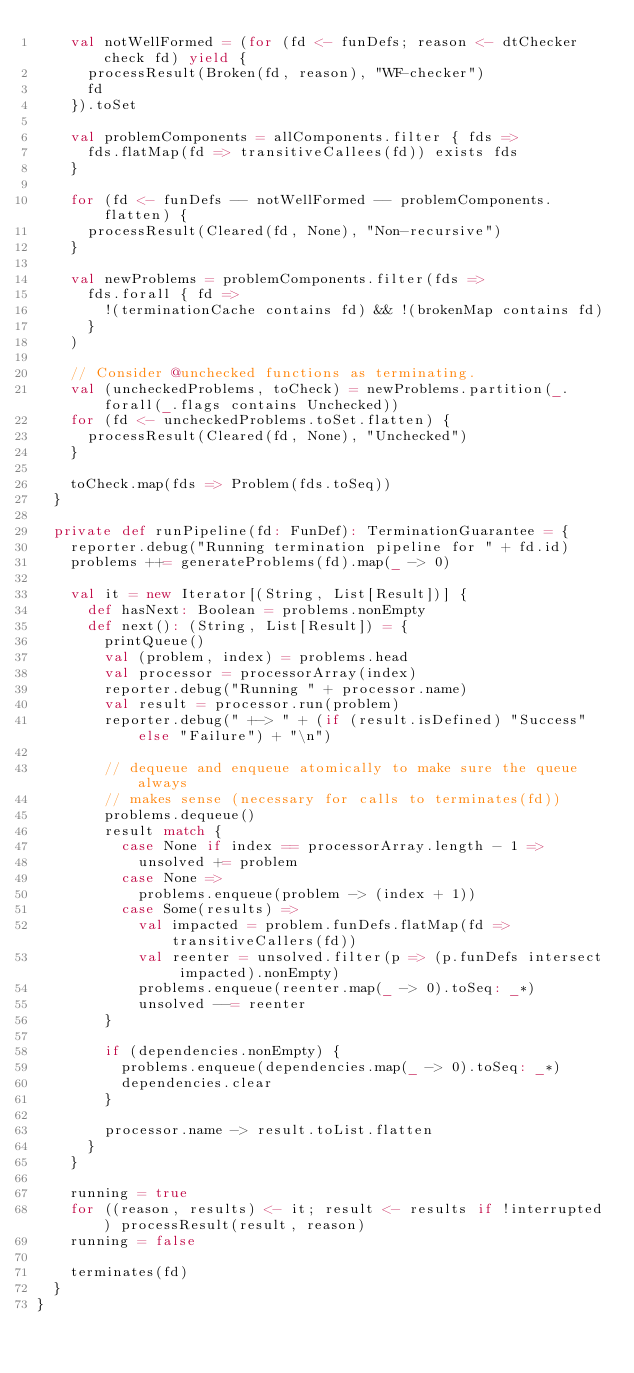<code> <loc_0><loc_0><loc_500><loc_500><_Scala_>    val notWellFormed = (for (fd <- funDefs; reason <- dtChecker check fd) yield {
      processResult(Broken(fd, reason), "WF-checker")
      fd
    }).toSet

    val problemComponents = allComponents.filter { fds =>
      fds.flatMap(fd => transitiveCallees(fd)) exists fds
    }

    for (fd <- funDefs -- notWellFormed -- problemComponents.flatten) {
      processResult(Cleared(fd, None), "Non-recursive")
    }

    val newProblems = problemComponents.filter(fds =>
      fds.forall { fd =>
        !(terminationCache contains fd) && !(brokenMap contains fd)
      }
    )

    // Consider @unchecked functions as terminating.
    val (uncheckedProblems, toCheck) = newProblems.partition(_.forall(_.flags contains Unchecked))
    for (fd <- uncheckedProblems.toSet.flatten) {
      processResult(Cleared(fd, None), "Unchecked")
    }

    toCheck.map(fds => Problem(fds.toSeq))
  }

  private def runPipeline(fd: FunDef): TerminationGuarantee = {
    reporter.debug("Running termination pipeline for " + fd.id)
    problems ++= generateProblems(fd).map(_ -> 0)

    val it = new Iterator[(String, List[Result])] {
      def hasNext: Boolean = problems.nonEmpty
      def next(): (String, List[Result]) = {
        printQueue()
        val (problem, index) = problems.head
        val processor = processorArray(index)
        reporter.debug("Running " + processor.name)
        val result = processor.run(problem)
        reporter.debug(" +-> " + (if (result.isDefined) "Success" else "Failure") + "\n")

        // dequeue and enqueue atomically to make sure the queue always
        // makes sense (necessary for calls to terminates(fd))
        problems.dequeue()
        result match {
          case None if index == processorArray.length - 1 =>
            unsolved += problem
          case None =>
            problems.enqueue(problem -> (index + 1))
          case Some(results) =>
            val impacted = problem.funDefs.flatMap(fd => transitiveCallers(fd))
            val reenter = unsolved.filter(p => (p.funDefs intersect impacted).nonEmpty)
            problems.enqueue(reenter.map(_ -> 0).toSeq: _*)
            unsolved --= reenter
        }

        if (dependencies.nonEmpty) {
          problems.enqueue(dependencies.map(_ -> 0).toSeq: _*)
          dependencies.clear
        }

        processor.name -> result.toList.flatten
      }
    }

    running = true
    for ((reason, results) <- it; result <- results if !interrupted) processResult(result, reason)
    running = false

    terminates(fd)
  }
}
</code> 